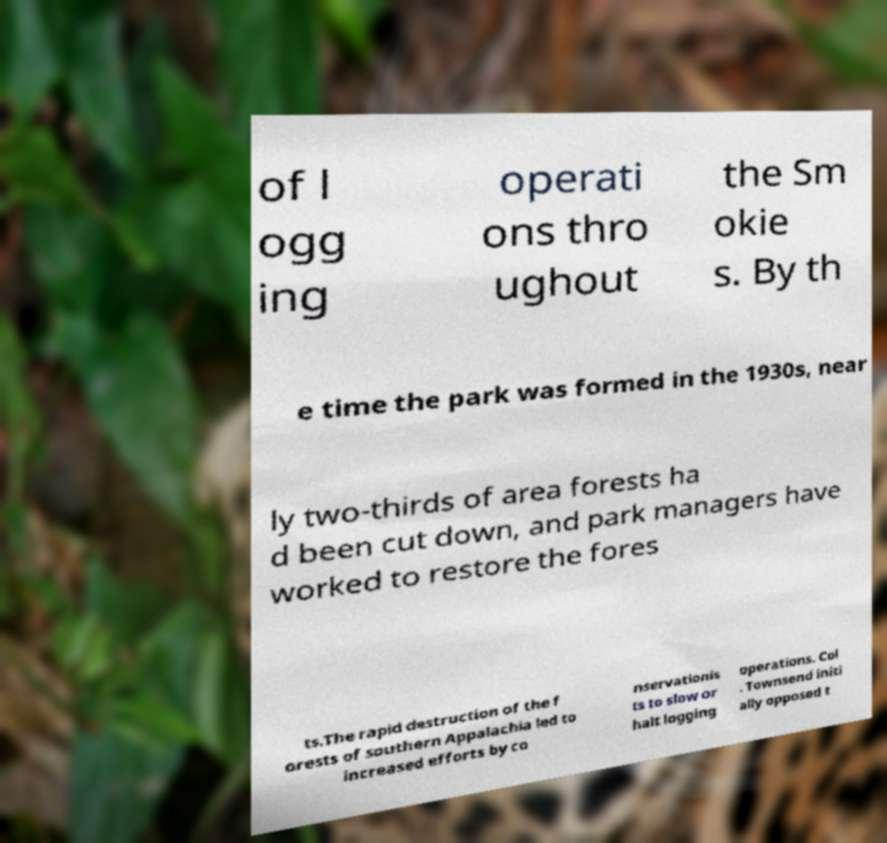Please read and relay the text visible in this image. What does it say? of l ogg ing operati ons thro ughout the Sm okie s. By th e time the park was formed in the 1930s, near ly two-thirds of area forests ha d been cut down, and park managers have worked to restore the fores ts.The rapid destruction of the f orests of southern Appalachia led to increased efforts by co nservationis ts to slow or halt logging operations. Col . Townsend initi ally opposed t 